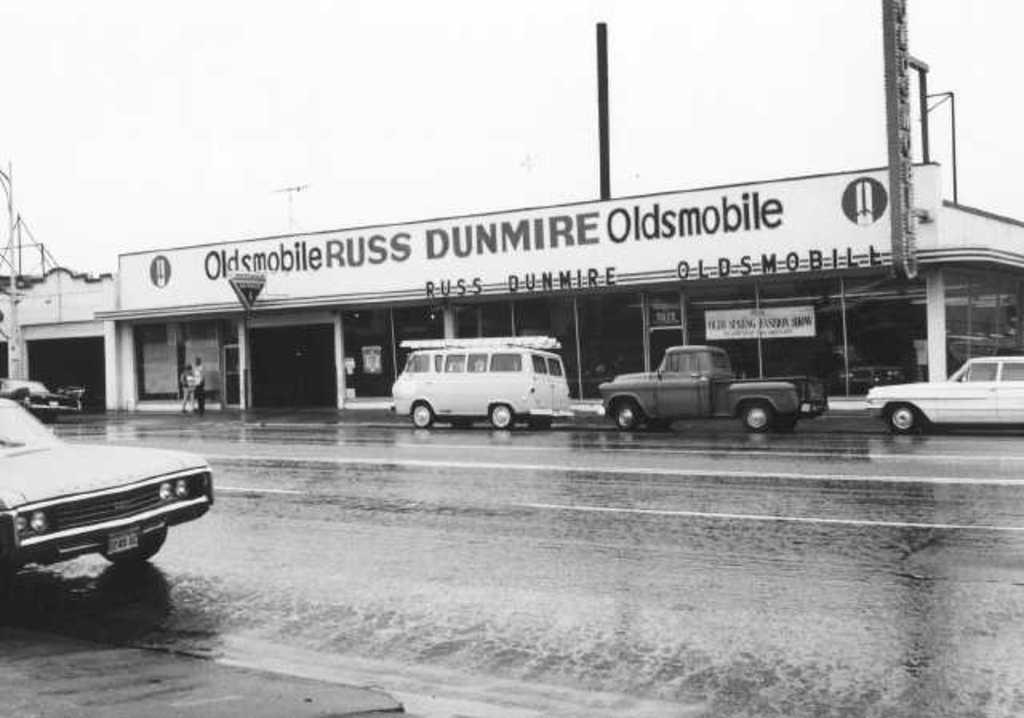How would you summarize this image in a sentence or two? This image consists of many vehicles on the road. At the bottom, there is a road. In the front, we can see a building on which there is text. At the top, there is sky. 